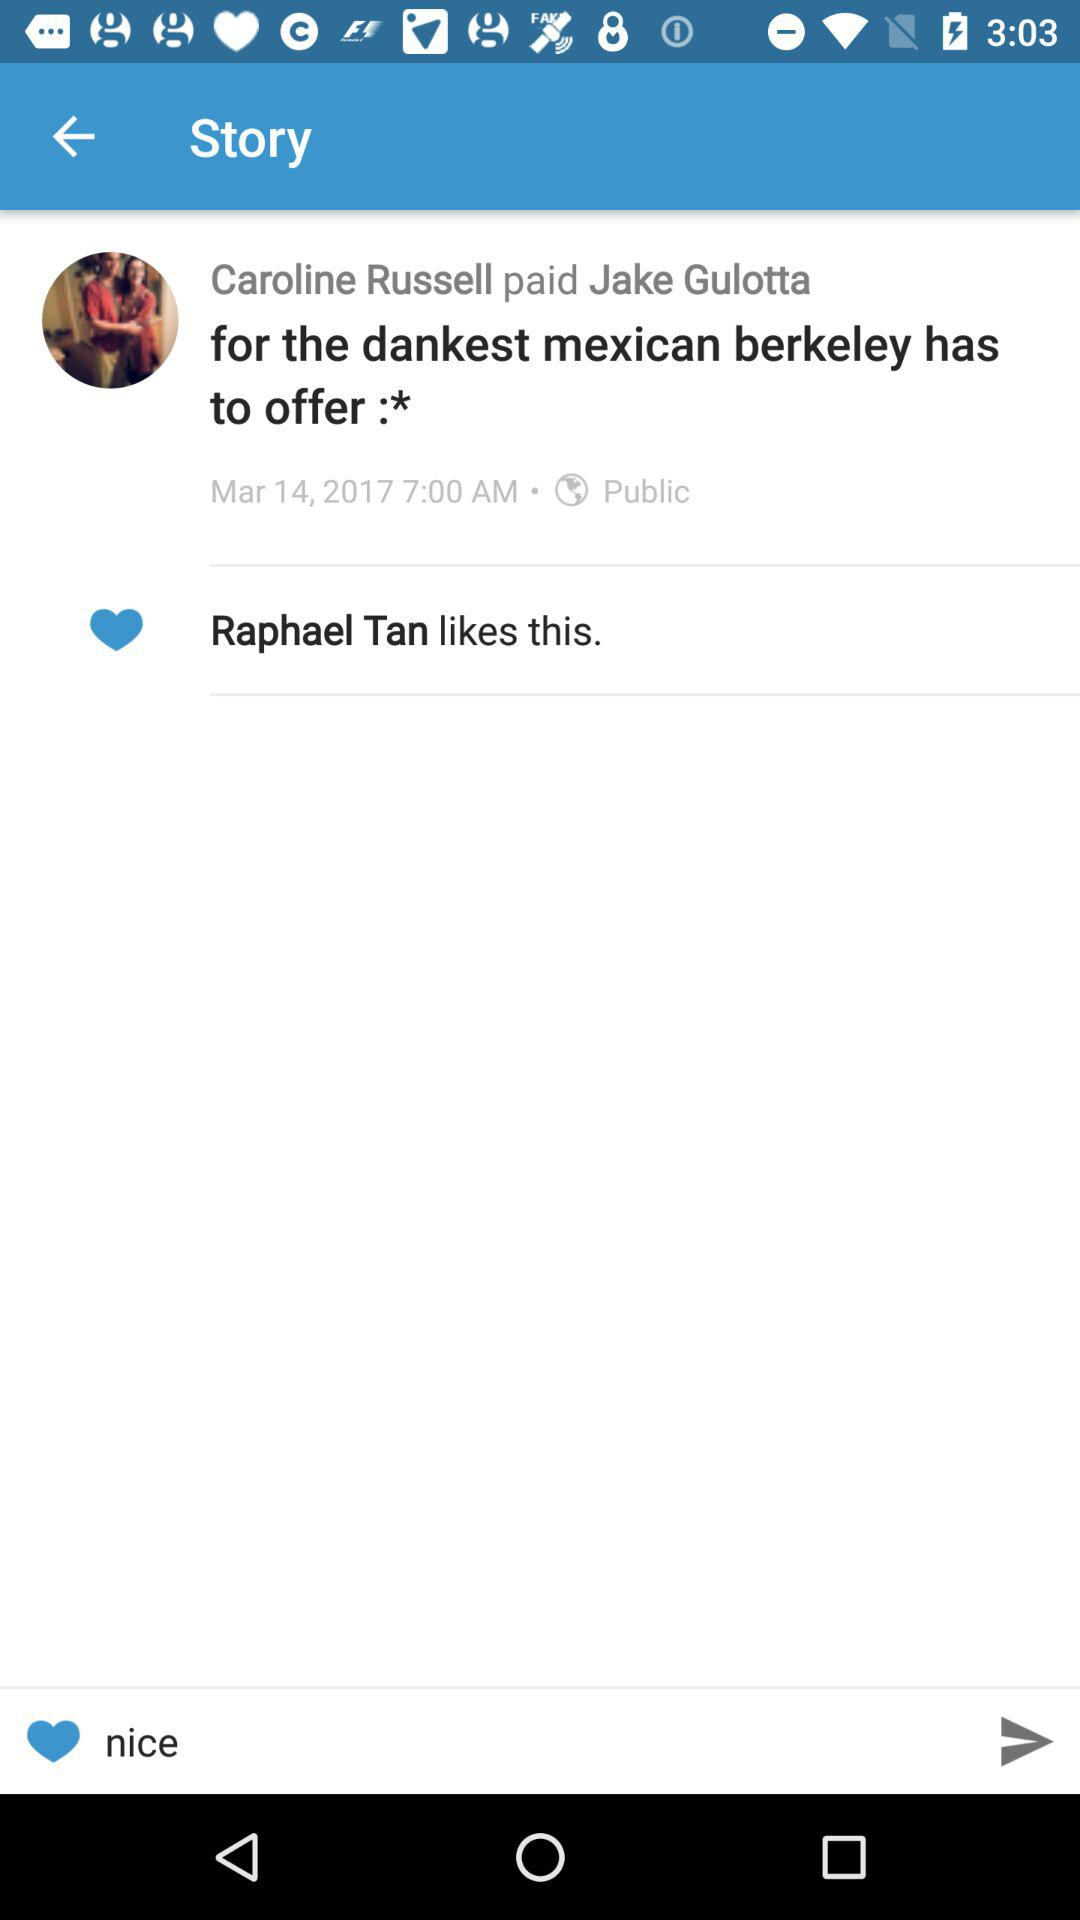On what date was the story posted? The story was posted on March 14, 2017. 